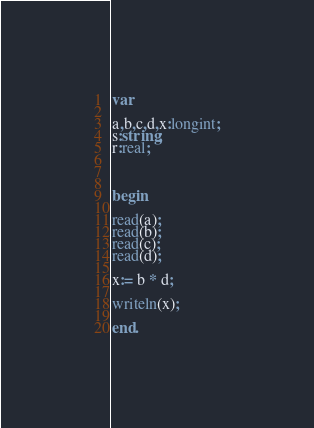<code> <loc_0><loc_0><loc_500><loc_500><_Pascal_>var

a,b,c,d,x:longint;
s:string;
r:real;



begin

read(a);
read(b);
read(c);
read(d);

x:= b * d;

writeln(x);

end.</code> 